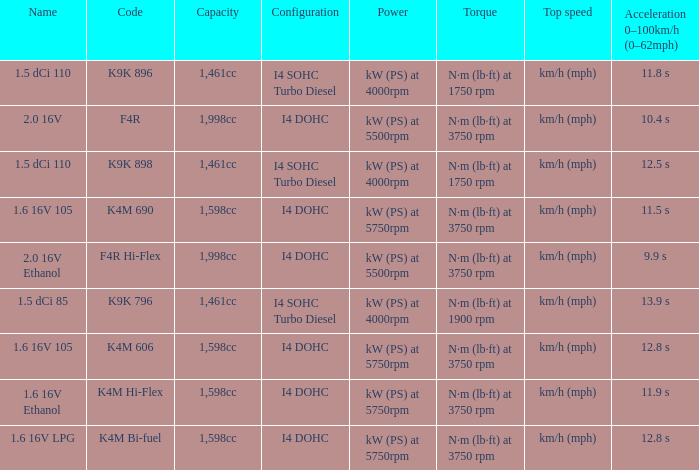What is the capacity of code f4r? 1,998cc. 